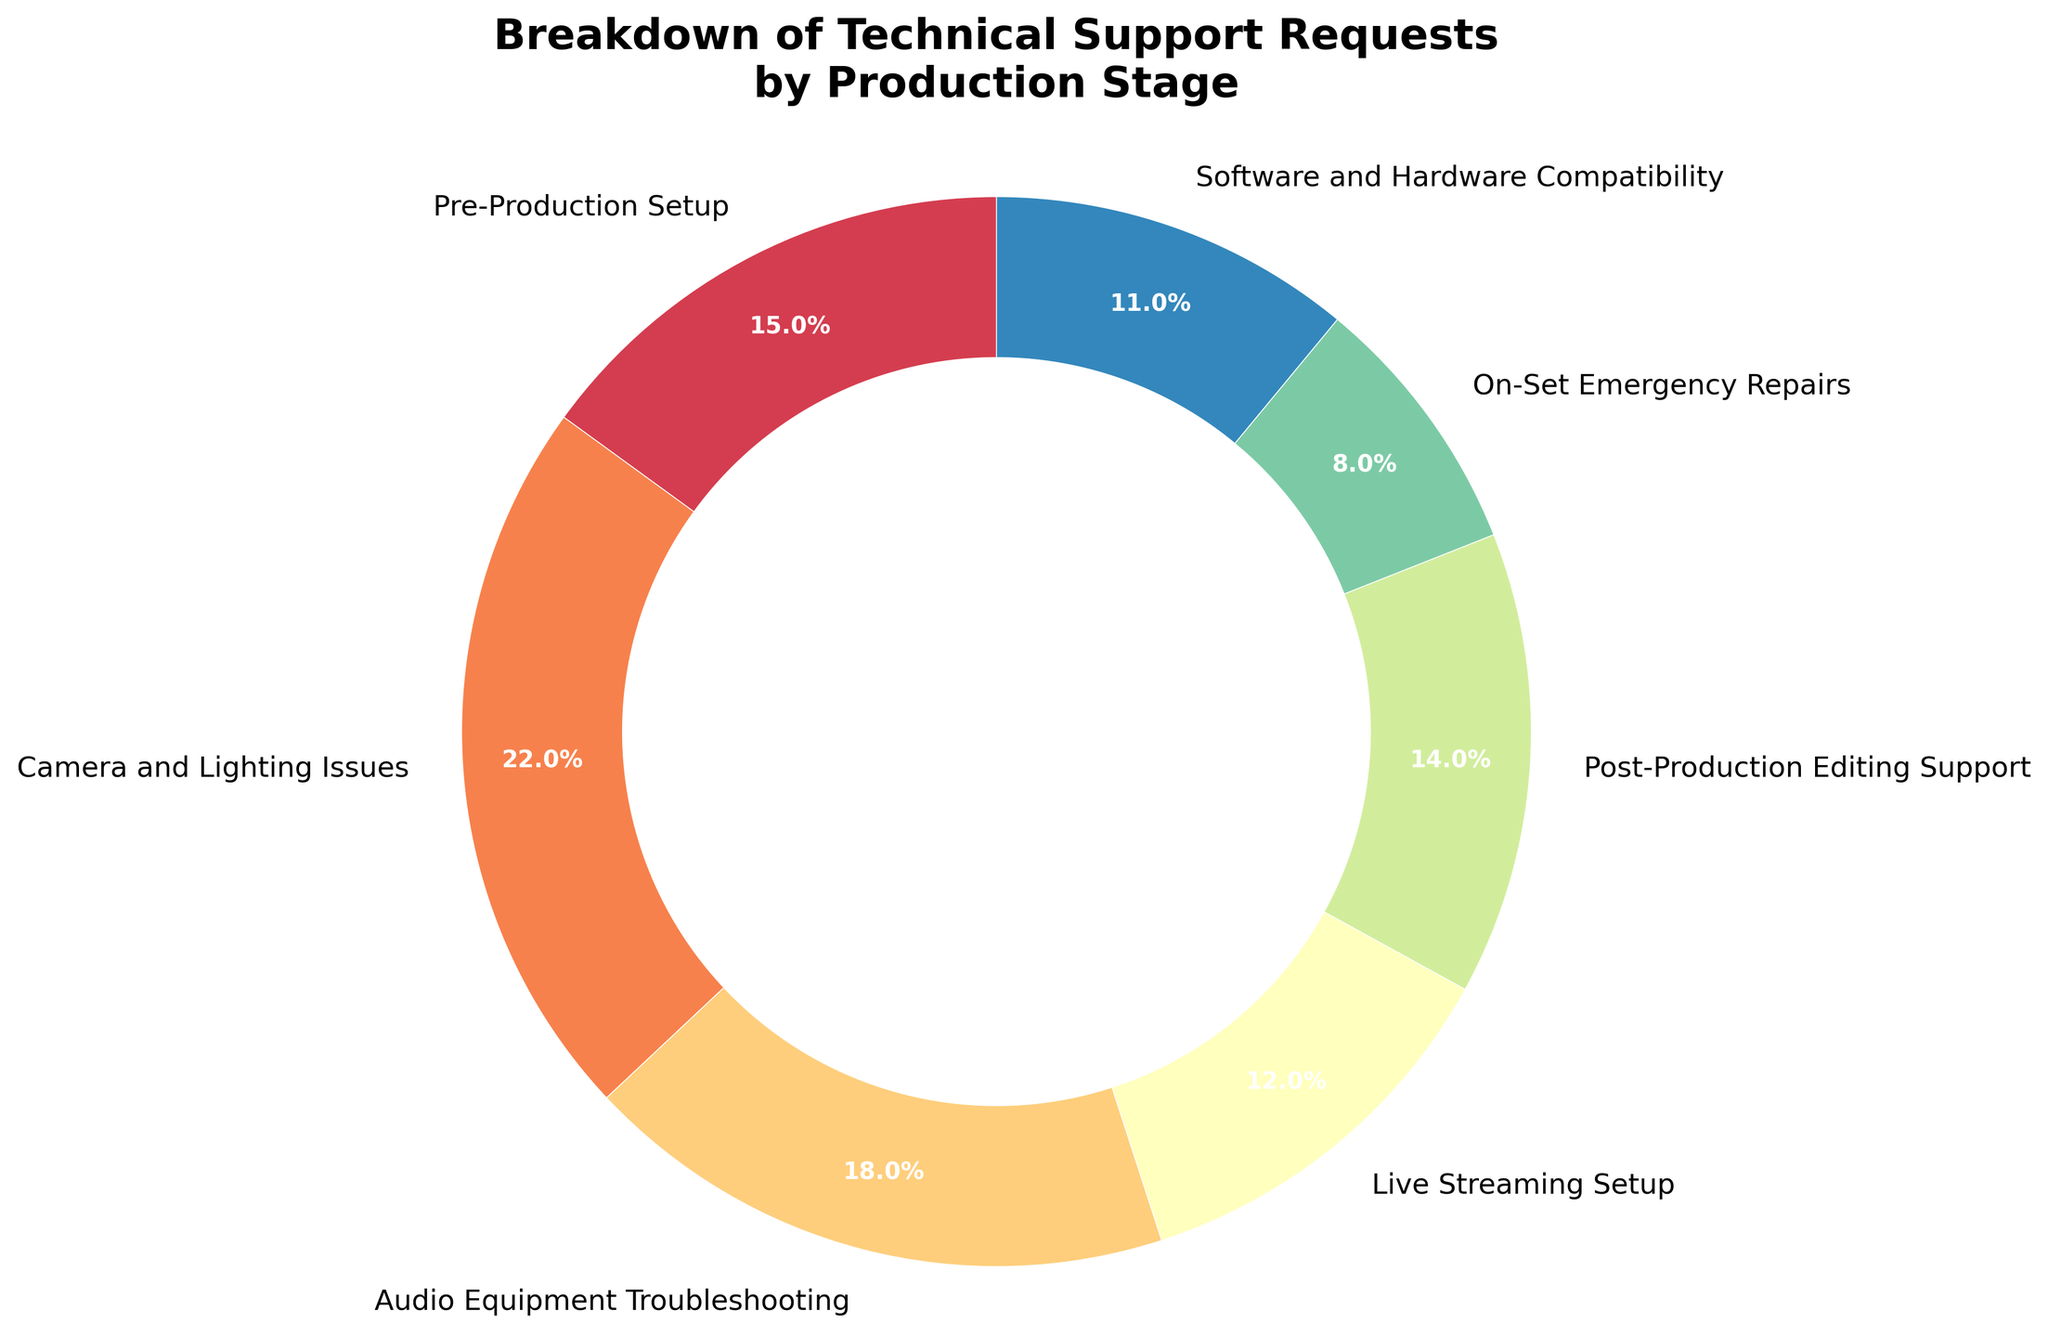What percentage of technical support requests are for Camera and Lighting Issues? Camera and Lighting Issues are labeled with a percentage of 22% in the pie chart.
Answer: 22% Which stage has the smallest percentage of technical support requests? Upon examining the pie chart, On-Set Emergency Repairs has the smallest segment, indicated by 8%.
Answer: On-Set Emergency Repairs What is the combined percentage for Pre-Production Setup and Live Streaming Setup? Pre-Production Setup is 15% and Live Streaming Setup is 12%, adding them together gives 15% + 12% = 27%.
Answer: 27% How much higher is the percentage of Audio Equipment Troubleshooting compared to On-Set Emergency Repairs? Audio Equipment Troubleshooting is 18% and On-Set Emergency Repairs is 8%. Subtraction of the percentages yields 18% - 8% = 10%.
Answer: 10% Which two stages together account for more than 30% of the requests? Camera and Lighting Issues is 22%, and combining it with any stage with more than 8% will suffice. One such combination is Camera and Lighting Issues (22%) + Audio Equipment Troubleshooting (18%) = 40%.
Answer: Camera and Lighting Issues and Audio Equipment Troubleshooting Are there more requests for Live Streaming Setup or Software and Hardware Compatibility? Live Streaming Setup is 12% while Software and Hardware Compatibility is 11%. Therefore, Live Streaming Setup has more requests.
Answer: Live Streaming Setup What is the average percentage of support requests for Post-Production Editing Support, Pre-Production Setup, and Software and Hardware Compatibility? Summing up the percentages of these three stages: 14% + 15% + 11% = 40%. The average is 40% / 3 ≈ 13.33%.
Answer: 13.33% What percentage of support requests are related to setups (combining Pre-Production and Live Streaming)? Pre-Production Setup is 15% and Live Streaming Setup is 12%. Adding these together gives 15% + 12% = 27%.
Answer: 27% Which stage has a greater support request percentage: Post-Production Editing Support or Audio Equipment Troubleshooting? Post-Production Editing Support is 14%, and Audio Equipment Troubleshooting is 18%. Audio Equipment Troubleshooting is greater.
Answer: Audio Equipment Troubleshooting 